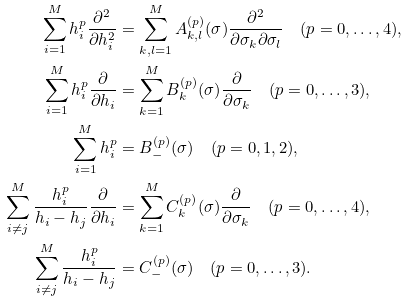Convert formula to latex. <formula><loc_0><loc_0><loc_500><loc_500>\sum _ { i = 1 } ^ { M } h _ { i } ^ { p } \frac { \partial ^ { 2 } } { \partial h _ { i } ^ { 2 } } & = \sum _ { k , l = 1 } ^ { M } A _ { k , l } ^ { ( p ) } ( \sigma ) \frac { \partial ^ { 2 } } { \partial \sigma _ { k } \partial \sigma _ { l } } \quad ( p = 0 , \dots , 4 ) , \\ \sum _ { i = 1 } ^ { M } h _ { i } ^ { p } \frac { \partial } { \partial h _ { i } } & = \sum _ { k = 1 } ^ { M } B _ { k } ^ { ( p ) } ( \sigma ) \frac { \partial } { \partial \sigma _ { k } } \quad ( p = 0 , \dots , 3 ) , \\ \sum _ { i = 1 } ^ { M } h _ { i } ^ { p } & = B _ { - } ^ { ( p ) } ( \sigma ) \quad ( p = 0 , 1 , 2 ) , \\ \sum _ { i \neq j } ^ { M } \frac { h _ { i } ^ { p } } { h _ { i } - h _ { j } } \frac { \partial } { \partial h _ { i } } & = \sum _ { k = 1 } ^ { M } C _ { k } ^ { ( p ) } ( \sigma ) \frac { \partial } { \partial \sigma _ { k } } \quad ( p = 0 , \dots , 4 ) , \\ \sum _ { i \neq j } ^ { M } \frac { h _ { i } ^ { p } } { h _ { i } - h _ { j } } & = C _ { - } ^ { ( p ) } ( \sigma ) \quad ( p = 0 , \dots , 3 ) .</formula> 